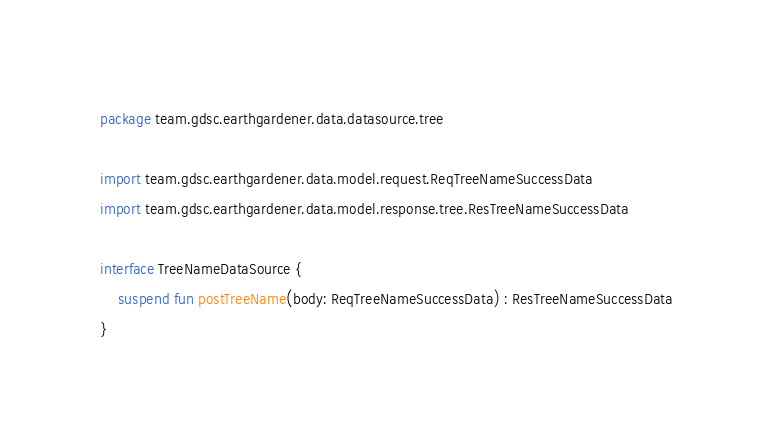<code> <loc_0><loc_0><loc_500><loc_500><_Kotlin_>package team.gdsc.earthgardener.data.datasource.tree

import team.gdsc.earthgardener.data.model.request.ReqTreeNameSuccessData
import team.gdsc.earthgardener.data.model.response.tree.ResTreeNameSuccessData

interface TreeNameDataSource {
    suspend fun postTreeName(body: ReqTreeNameSuccessData) : ResTreeNameSuccessData
}</code> 